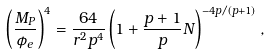<formula> <loc_0><loc_0><loc_500><loc_500>\left ( \frac { M _ { P } } { \phi _ { e } } \right ) ^ { 4 } = \frac { 6 4 } { r ^ { 2 } p ^ { 4 } } \left ( 1 + \frac { p + 1 } { p } N \right ) ^ { - 4 p / \left ( p + 1 \right ) } ,</formula> 